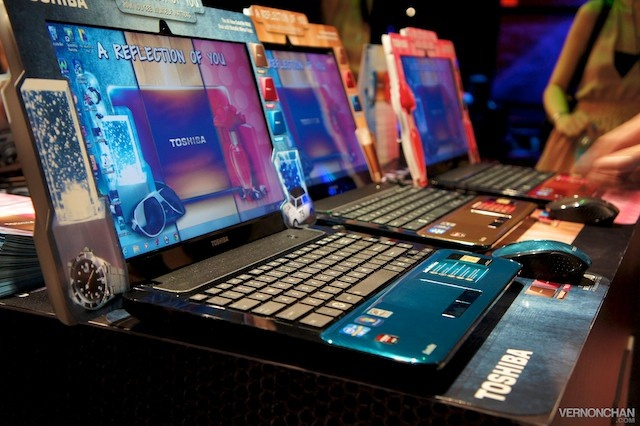Describe the objects in this image and their specific colors. I can see laptop in khaki, black, blue, gray, and darkgray tones, laptop in khaki, black, gray, darkblue, and brown tones, laptop in khaki, navy, salmon, black, and maroon tones, keyboard in khaki, black, tan, and gray tones, and people in khaki, maroon, brown, black, and olive tones in this image. 